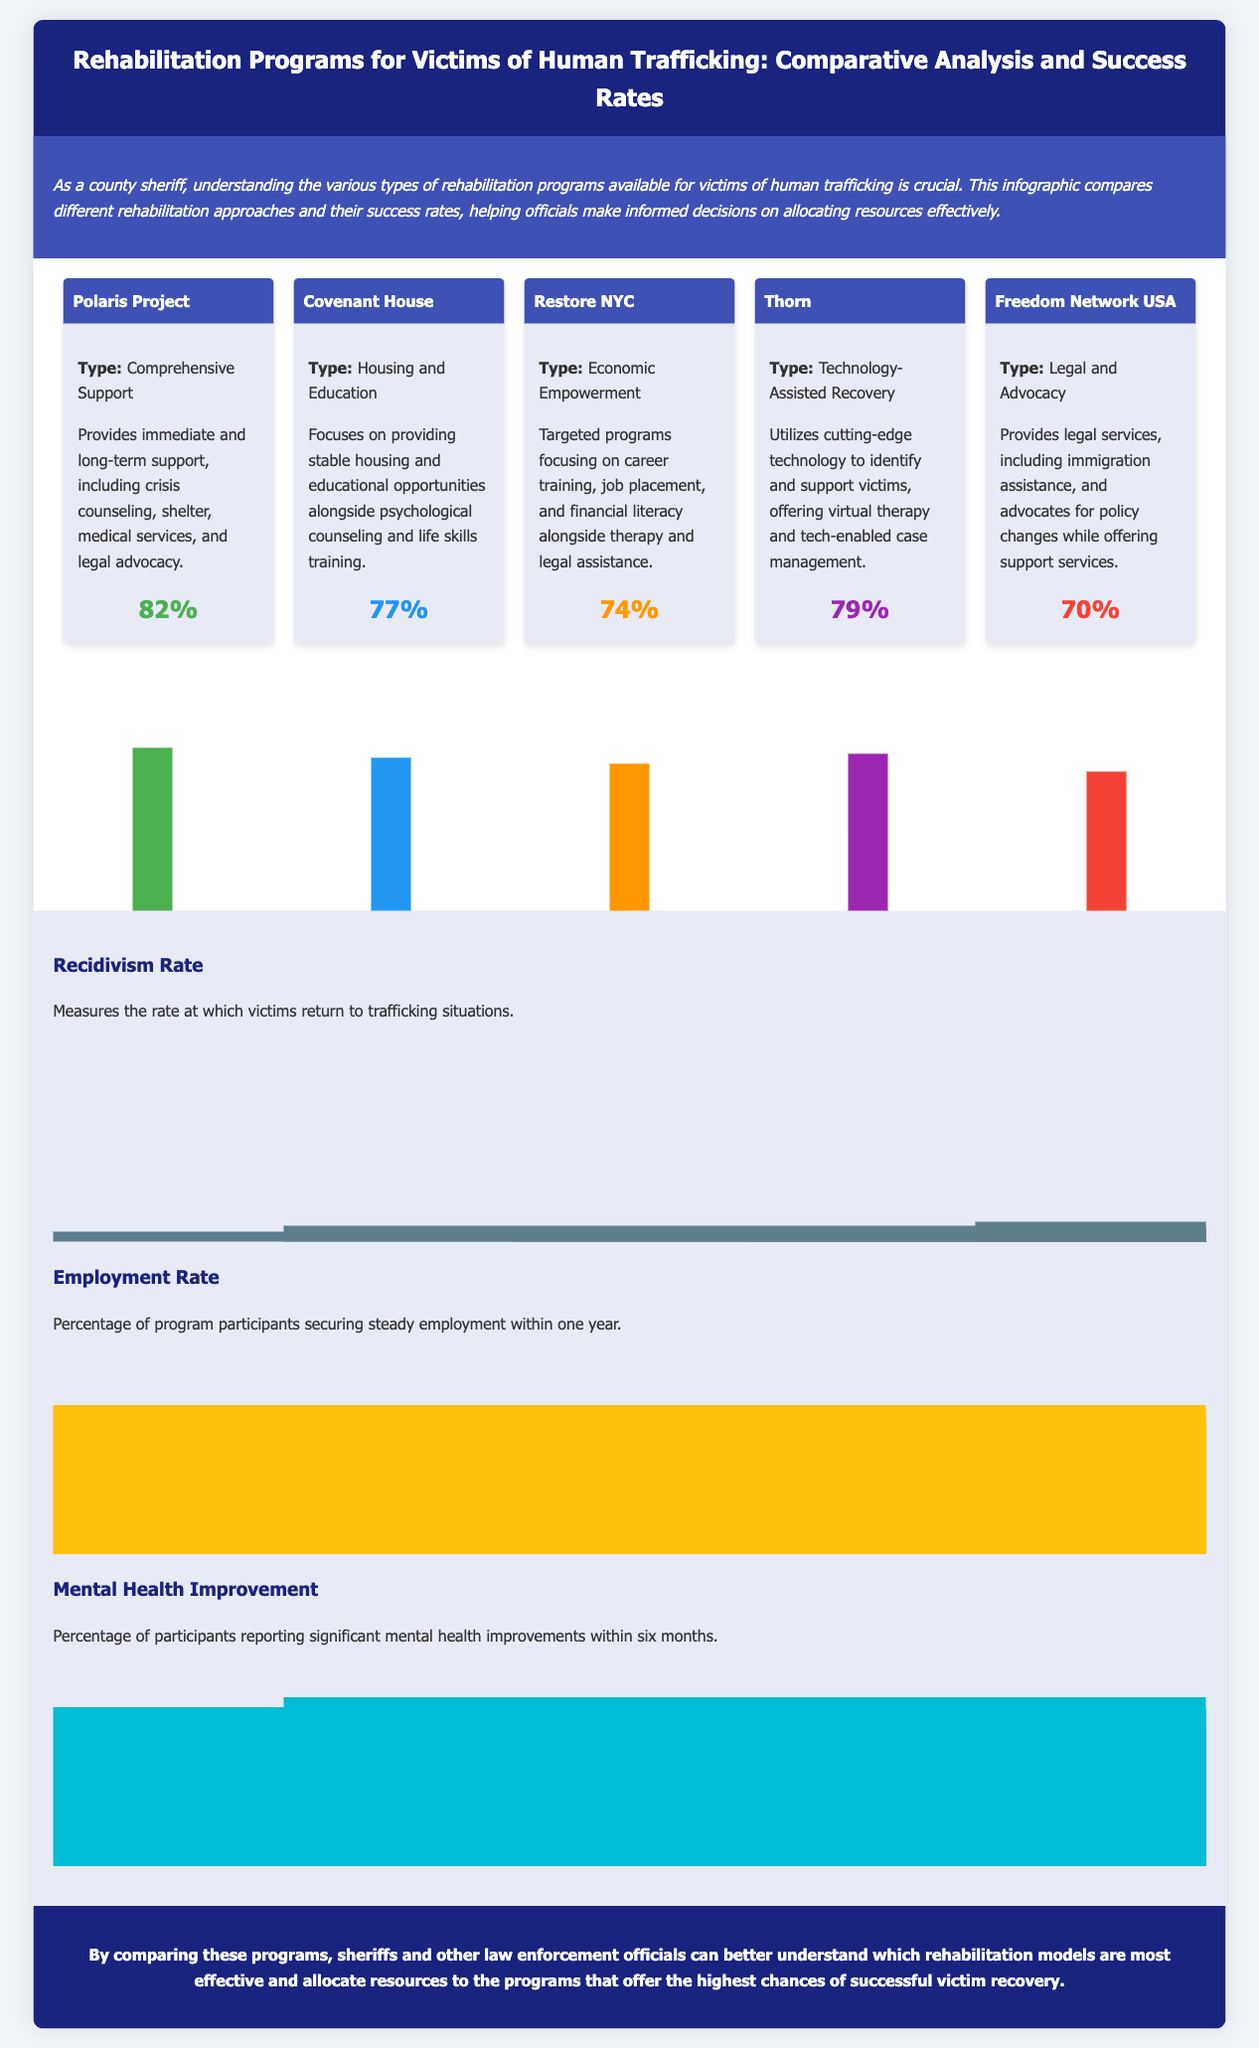What is the success rate of the Polaris Project? The success rate is directly stated in the document as 82%.
Answer: 82% What type of program is Freedom Network USA? The document specifies that Freedom Network USA offers Legal and Advocacy programs.
Answer: Legal and Advocacy What is the focus of Restore NYC? The document describes Restore NYC as focusing on Economic Empowerment.
Answer: Economic Empowerment Which program has the highest success rate? By comparing the success rates listed in the document, the Polaris Project is identified as having the highest rate at 82%.
Answer: Polaris Project What percentage of participants report significant mental health improvements within six months? The document provides that 80% of participants report significant mental health improvements.
Answer: 80% What is the success rate of Covenant House? The success rate for Covenant House is clearly stated in the document as 77%.
Answer: 77% Which program uses technology-assisted recovery? The document mentions the Thorn program as utilizing technology-assisted recovery.
Answer: Thorn What is the recidivism rate for the programs mentioned? The document shows multiple recidivism rates highlighted in a chart, with the lowest noted as 5%.
Answer: 5% Which program offers crisis counseling and shelter? The Polaris Project is specified in the document as providing crisis counseling and shelter.
Answer: Polaris Project 